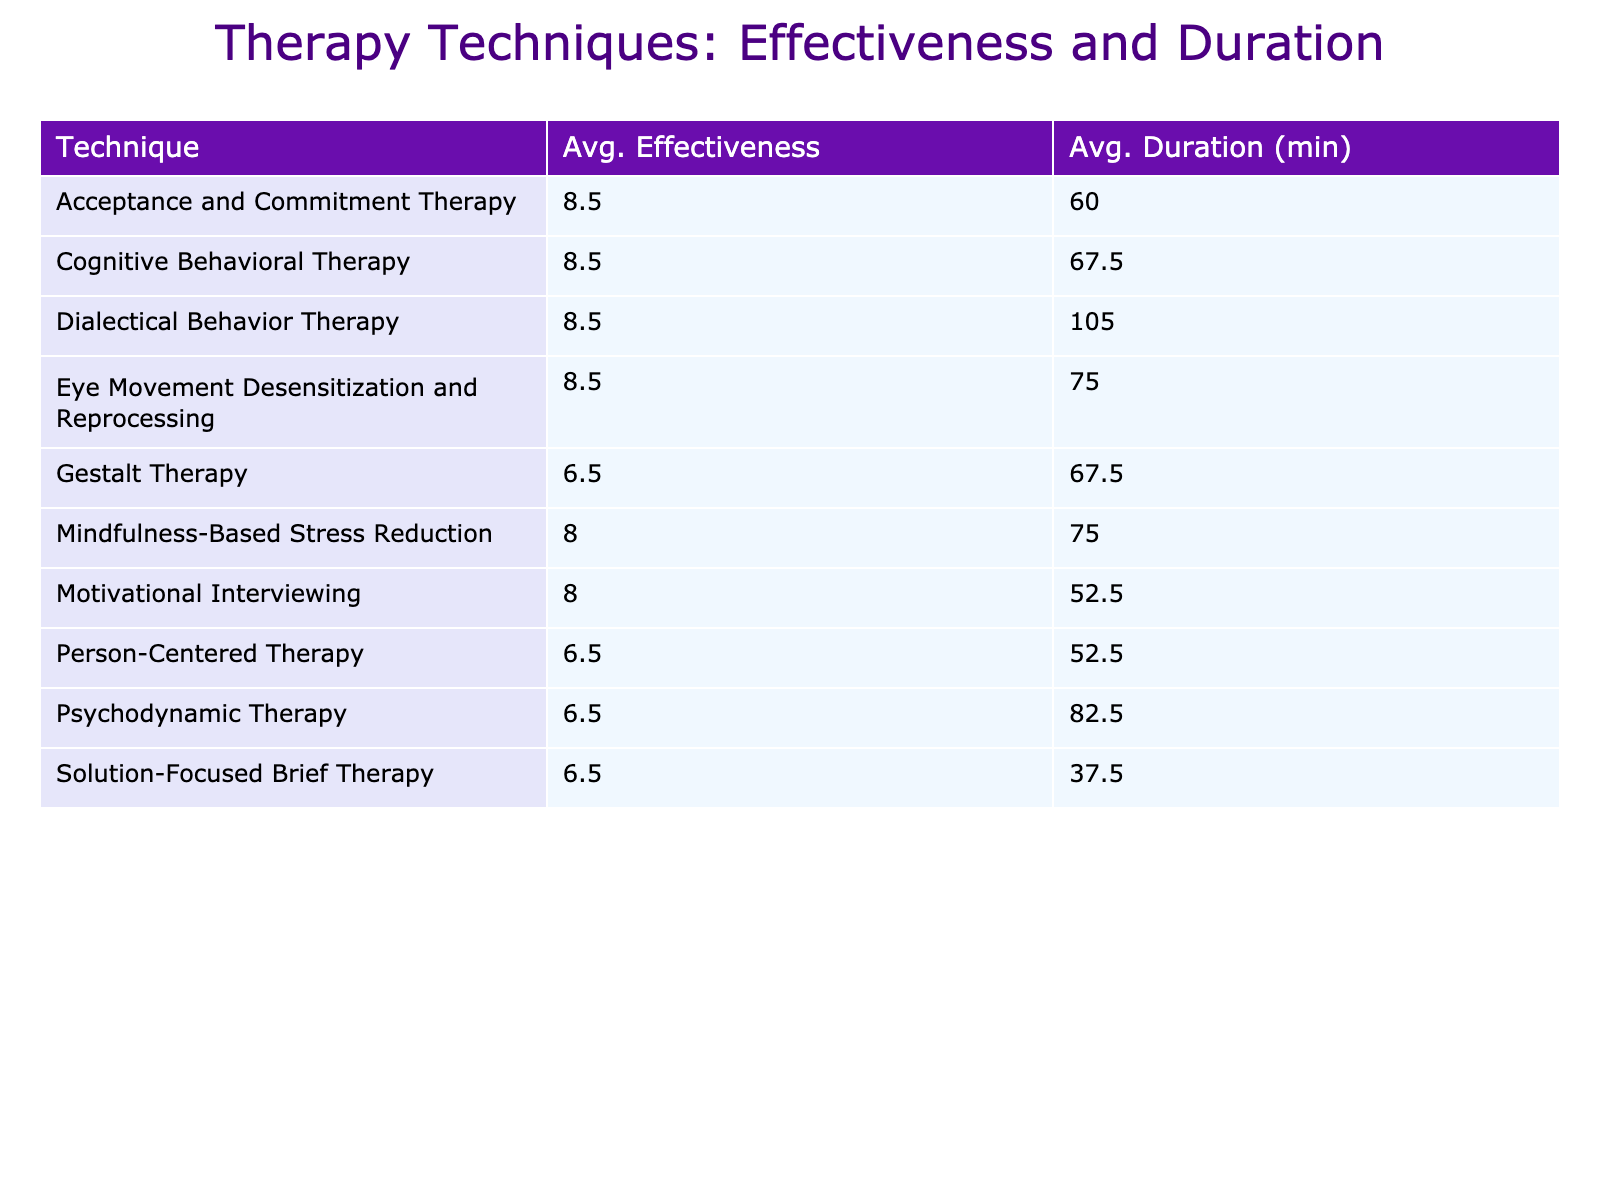What is the average effectiveness score for Eye Movement Desensitization and Reprocessing? The effectiveness score for Eye Movement Desensitization and Reprocessing is 9, which is given directly in the table.
Answer: 9 Which therapy technique has the longest average duration? The therapy techniques listed with their average durations show that Dialectical Behavior Therapy has the longest duration of 120 minutes.
Answer: Dialectical Behavior Therapy Is the average effectiveness score for Cognitive Behavioral Therapy above 8? The average effectiveness score for Cognitive Behavioral Therapy is calculated from the two entries (8 and 9), giving an average of (8 + 9) / 2 = 8.5, which is above 8.
Answer: Yes What is the total average effectiveness score for all techniques listed? The average effectiveness scores for each technique need to be summed up. Adding all scores (8 + 9 + 7 + 8 + 6 + 9 + 8 + 7 + 9 + 6 + 7 + 8 + 8 + 6 + 9) gives 120. There are 15 techniques, so the total average is 120 / 15 = 8.
Answer: 8 How many techniques have an average effectiveness score of 8 or higher? Review the effectiveness scores: (8, 9, 8, 9, 9, 8, 9). Count the techniques where the score is 8 or higher, which are 10 out of 15.
Answer: 10 What is the difference in average duration between Acceptance and Commitment Therapy and Solution-Focused Brief Therapy? The average duration for Acceptance and Commitment Therapy is 60 minutes and for Solution-Focused Brief Therapy is 45 minutes. The difference is 60 - 45 = 15 minutes.
Answer: 15 minutes Does any therapy technique have an average effectiveness score below 7? Looking through the table, Psychodynamic Therapy, Person-Centered Therapy, and Gestalt Therapy have scores below 7, confirming that at least one technique does meet this criterion.
Answer: Yes What is the median duration of all techniques listed? First, list the durations in order: 30, 45, 45, 60, 60, 60, 60, 75, 75, 90, 90, 120. With 15 data points, the median will be the 8th value, which is 60 minutes.
Answer: 60 minutes 